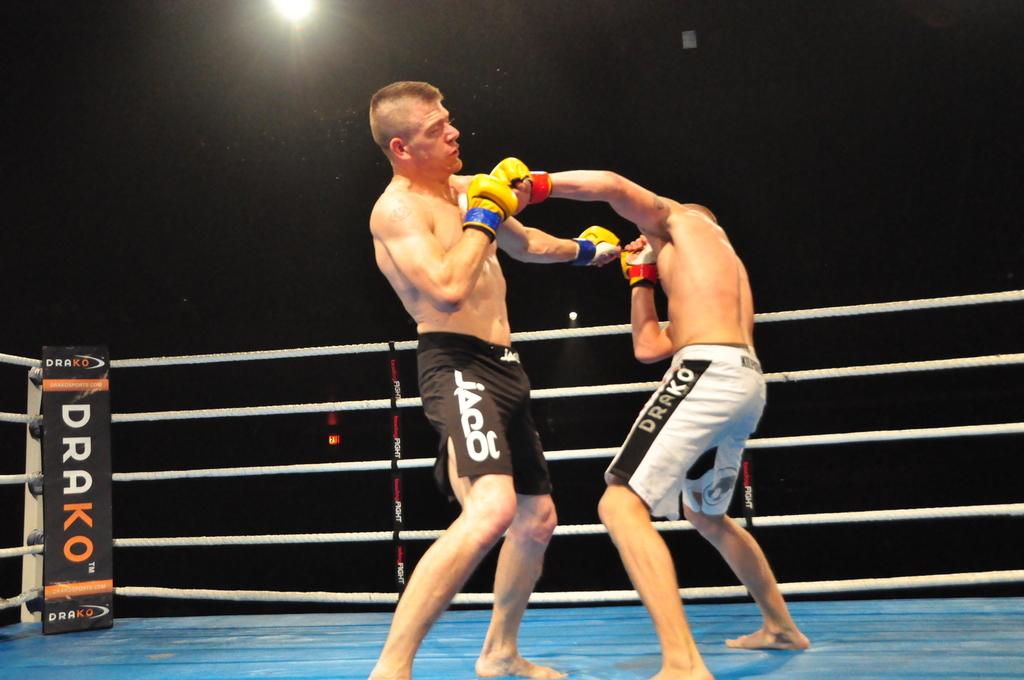What's written on the white shorts on the right?
Offer a terse response. Drako. 